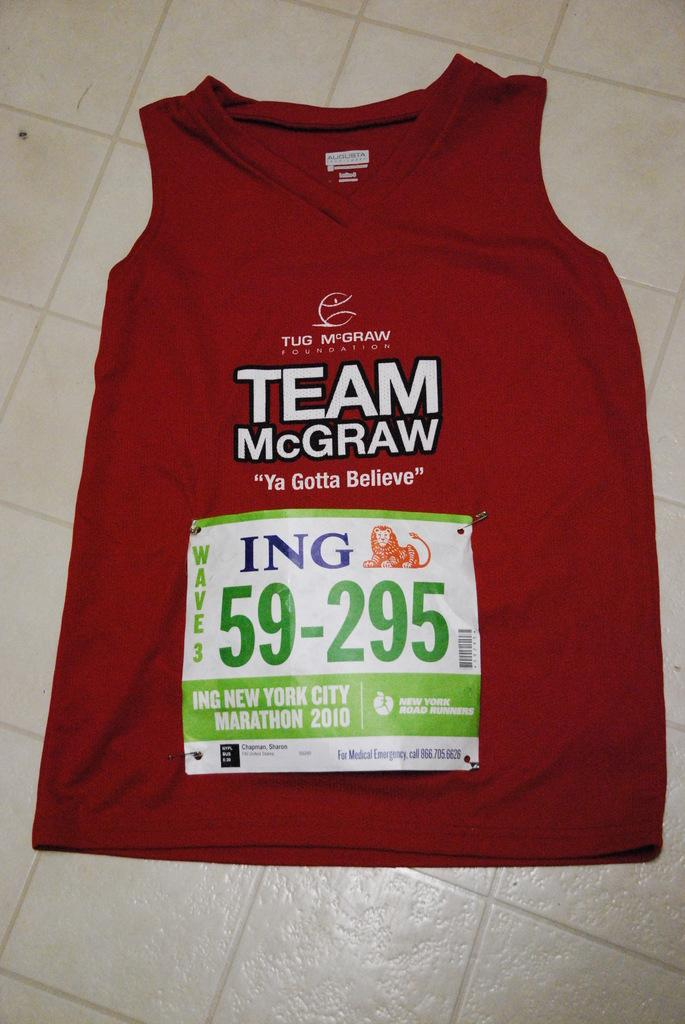<image>
Offer a succinct explanation of the picture presented. A red TEAM McGRAW shirt is labelled with the number 59-295. 